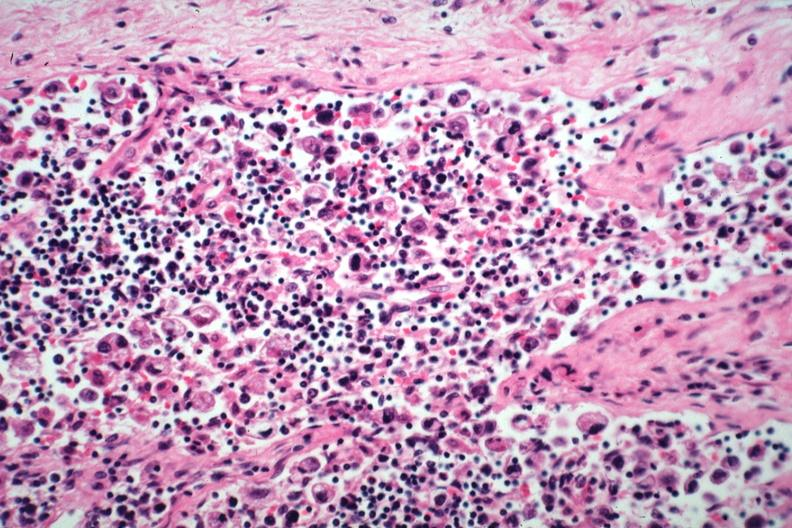what does this image show?
Answer the question using a single word or phrase. Anaplastic adenocarcinoma from stomach 